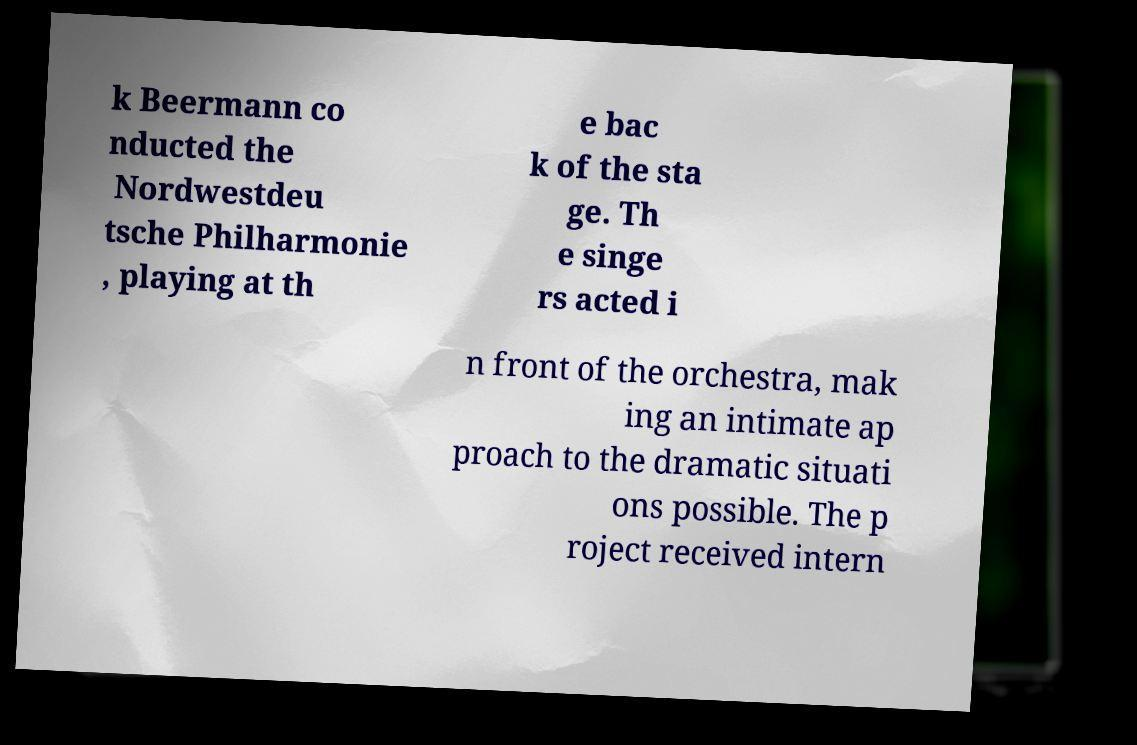There's text embedded in this image that I need extracted. Can you transcribe it verbatim? k Beermann co nducted the Nordwestdeu tsche Philharmonie , playing at th e bac k of the sta ge. Th e singe rs acted i n front of the orchestra, mak ing an intimate ap proach to the dramatic situati ons possible. The p roject received intern 